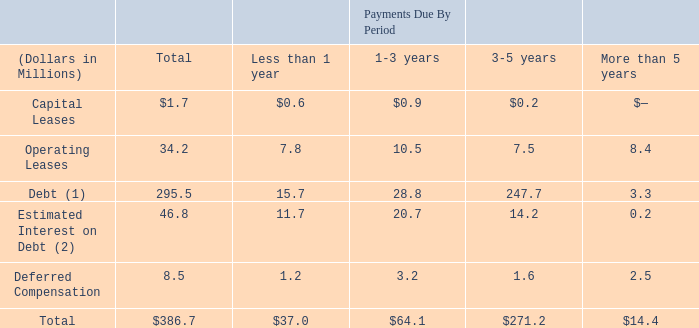Contractual Obligations
The following table summarizes contractual obligations and commitments, as of April 27, 2019:
(1) Assumes the outstanding borrowings under the revolving credit facility will be repaid upon maturity of the credit agreement in September 2023.
(2) Amounts represent estimated contractual interest payments on outstanding debt. Interest rates in effect as of April 27, 2019 are used for floating-rate debt.
We enter into agreements with suppliers to assist us in meeting our customers' production needs. These agreements vary as to duration and quantity commitments. Historically, most have been short-term agreements, which do not provide for minimum purchases, or are requirements-based contracts.
Why does the company enter into agreements with suppliers? To assist us in meeting our customers' production needs. What was the capital leases due in 1 year and 1-3 years respectively?
Answer scale should be: million. $0.6, $0.9. What was the total operating leases?
Answer scale should be: million. 34.2. What was the difference in the capital leases due from less than 1 year to those due in 1-3 years?
Answer scale should be: million. 0.9 - 0.6
Answer: 0.3. In which period was operating leases due less than 10 million? Locate and analyze operating leases in row 5
answer: less than 1 year, 3-5 years, more than 5 years. What percentage of the total was made of debt?
Answer scale should be: percent. 295.5 / 386.7
Answer: 76.42. 